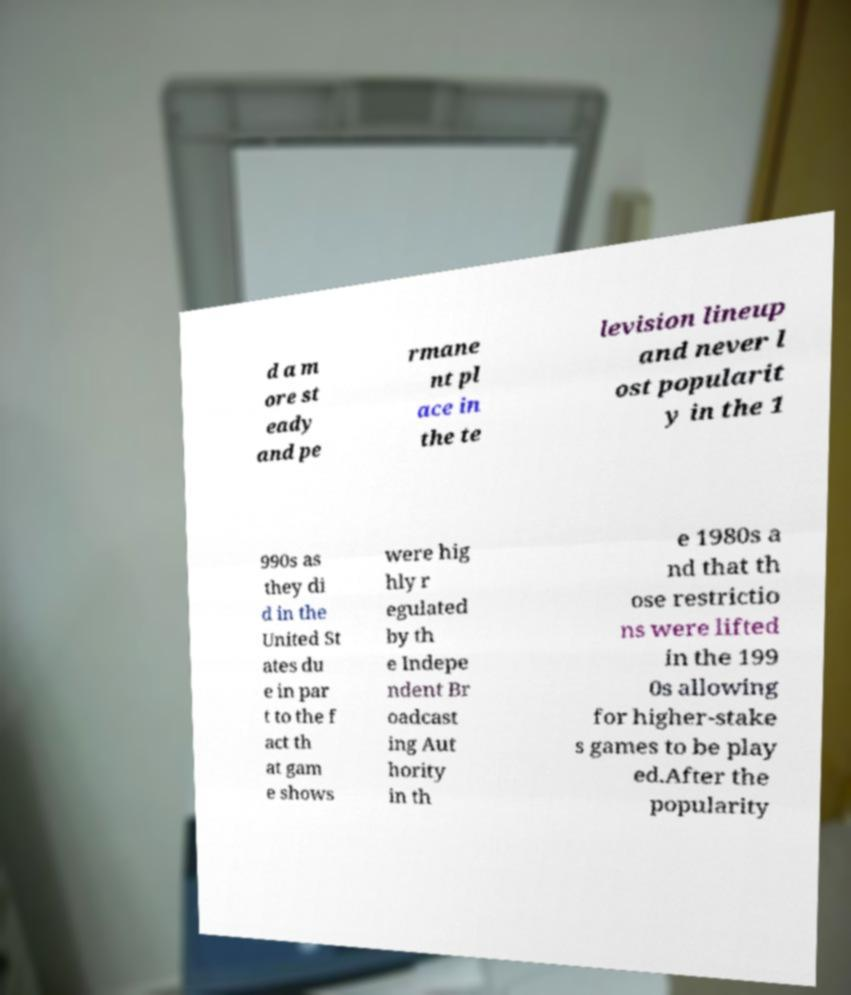I need the written content from this picture converted into text. Can you do that? d a m ore st eady and pe rmane nt pl ace in the te levision lineup and never l ost popularit y in the 1 990s as they di d in the United St ates du e in par t to the f act th at gam e shows were hig hly r egulated by th e Indepe ndent Br oadcast ing Aut hority in th e 1980s a nd that th ose restrictio ns were lifted in the 199 0s allowing for higher-stake s games to be play ed.After the popularity 